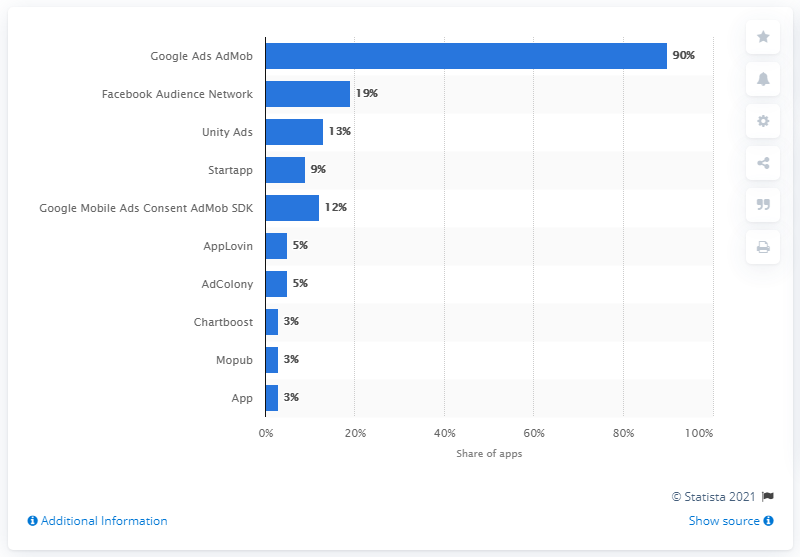Specify some key components in this picture. The Google Ads AdMob software development kit was the most popular mobile ad network. 